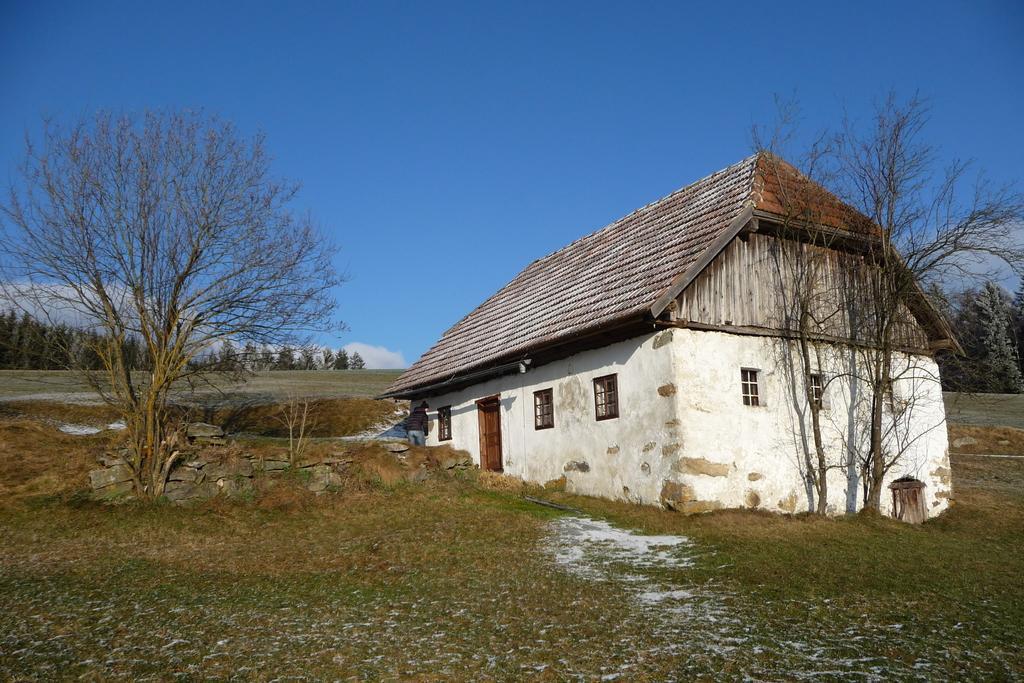Please provide a concise description of this image. In this image we can see one house, one object attached to the wall, there is a small rock wall near the house, some snow on the ground, some snow on the house, some dried trees, some snow on the trees, some trees and grass on the ground. At the top there is the blue sky with white clouds.   